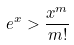Convert formula to latex. <formula><loc_0><loc_0><loc_500><loc_500>e ^ { x } > \frac { x ^ { m } } { m ! }</formula> 